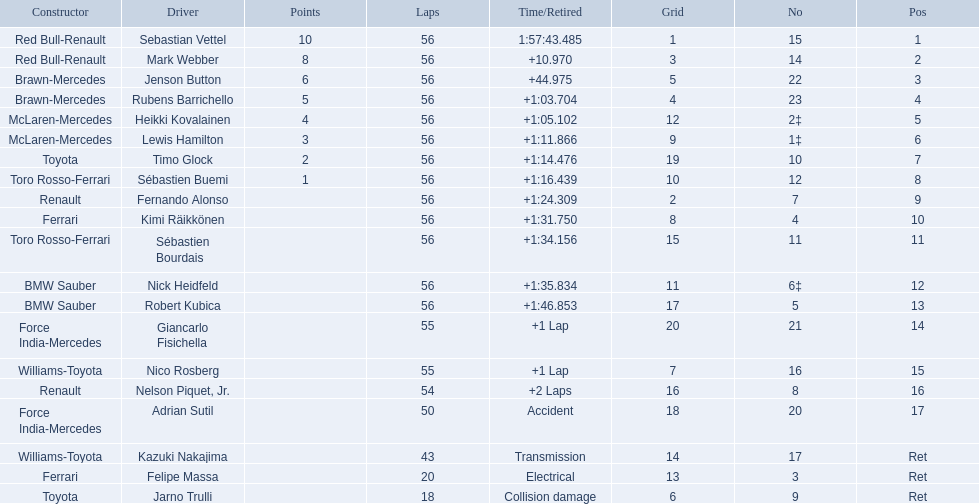Who were the drivers at the 2009 chinese grand prix? Sebastian Vettel, Mark Webber, Jenson Button, Rubens Barrichello, Heikki Kovalainen, Lewis Hamilton, Timo Glock, Sébastien Buemi, Fernando Alonso, Kimi Räikkönen, Sébastien Bourdais, Nick Heidfeld, Robert Kubica, Giancarlo Fisichella, Nico Rosberg, Nelson Piquet, Jr., Adrian Sutil, Kazuki Nakajima, Felipe Massa, Jarno Trulli. Who had the slowest time? Robert Kubica. 